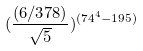Convert formula to latex. <formula><loc_0><loc_0><loc_500><loc_500>( \frac { ( 6 / 3 7 8 ) } { \sqrt { 5 } } ) ^ { ( 7 4 ^ { 4 } - 1 9 5 ) }</formula> 